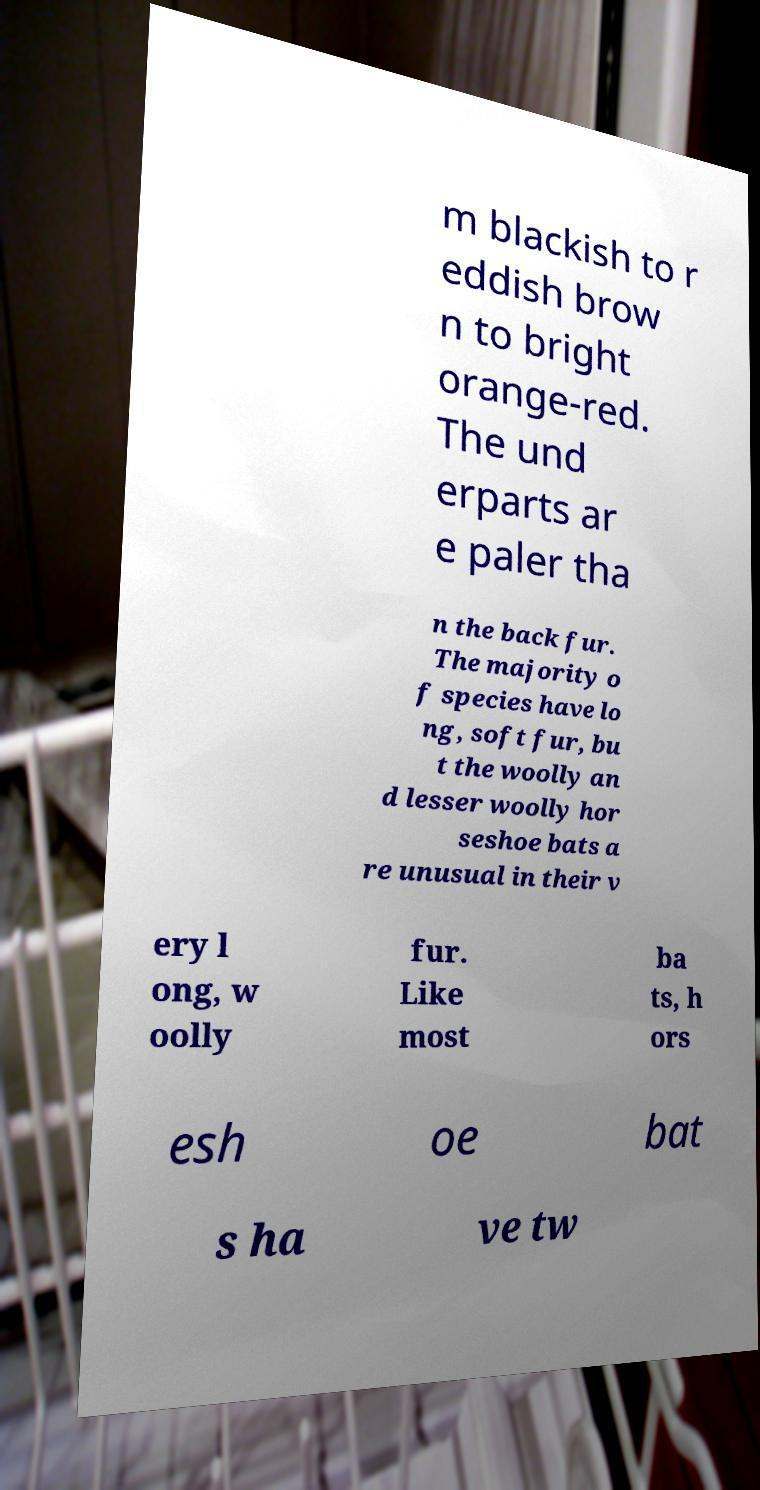Can you accurately transcribe the text from the provided image for me? m blackish to r eddish brow n to bright orange-red. The und erparts ar e paler tha n the back fur. The majority o f species have lo ng, soft fur, bu t the woolly an d lesser woolly hor seshoe bats a re unusual in their v ery l ong, w oolly fur. Like most ba ts, h ors esh oe bat s ha ve tw 